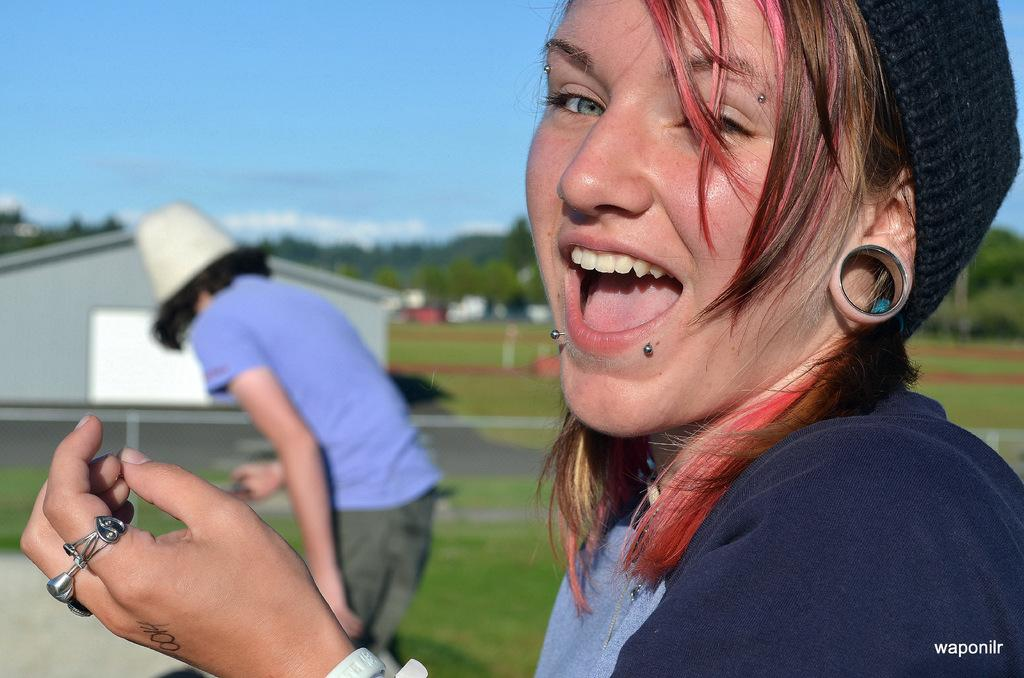Who is present in the image? There is a woman in the image. What is the woman doing in the image? The woman is standing and smiling. Can you describe the person standing in front of the woman? There is a person standing in front of the woman, but no specific details are provided. What type of natural environment is visible in the image? There is grass, trees, and the sky visible in the image. What type of test is being conducted on the canvas in the image? There is no canvas or test present in the image; it features a woman standing and smiling with another person in front of her. 